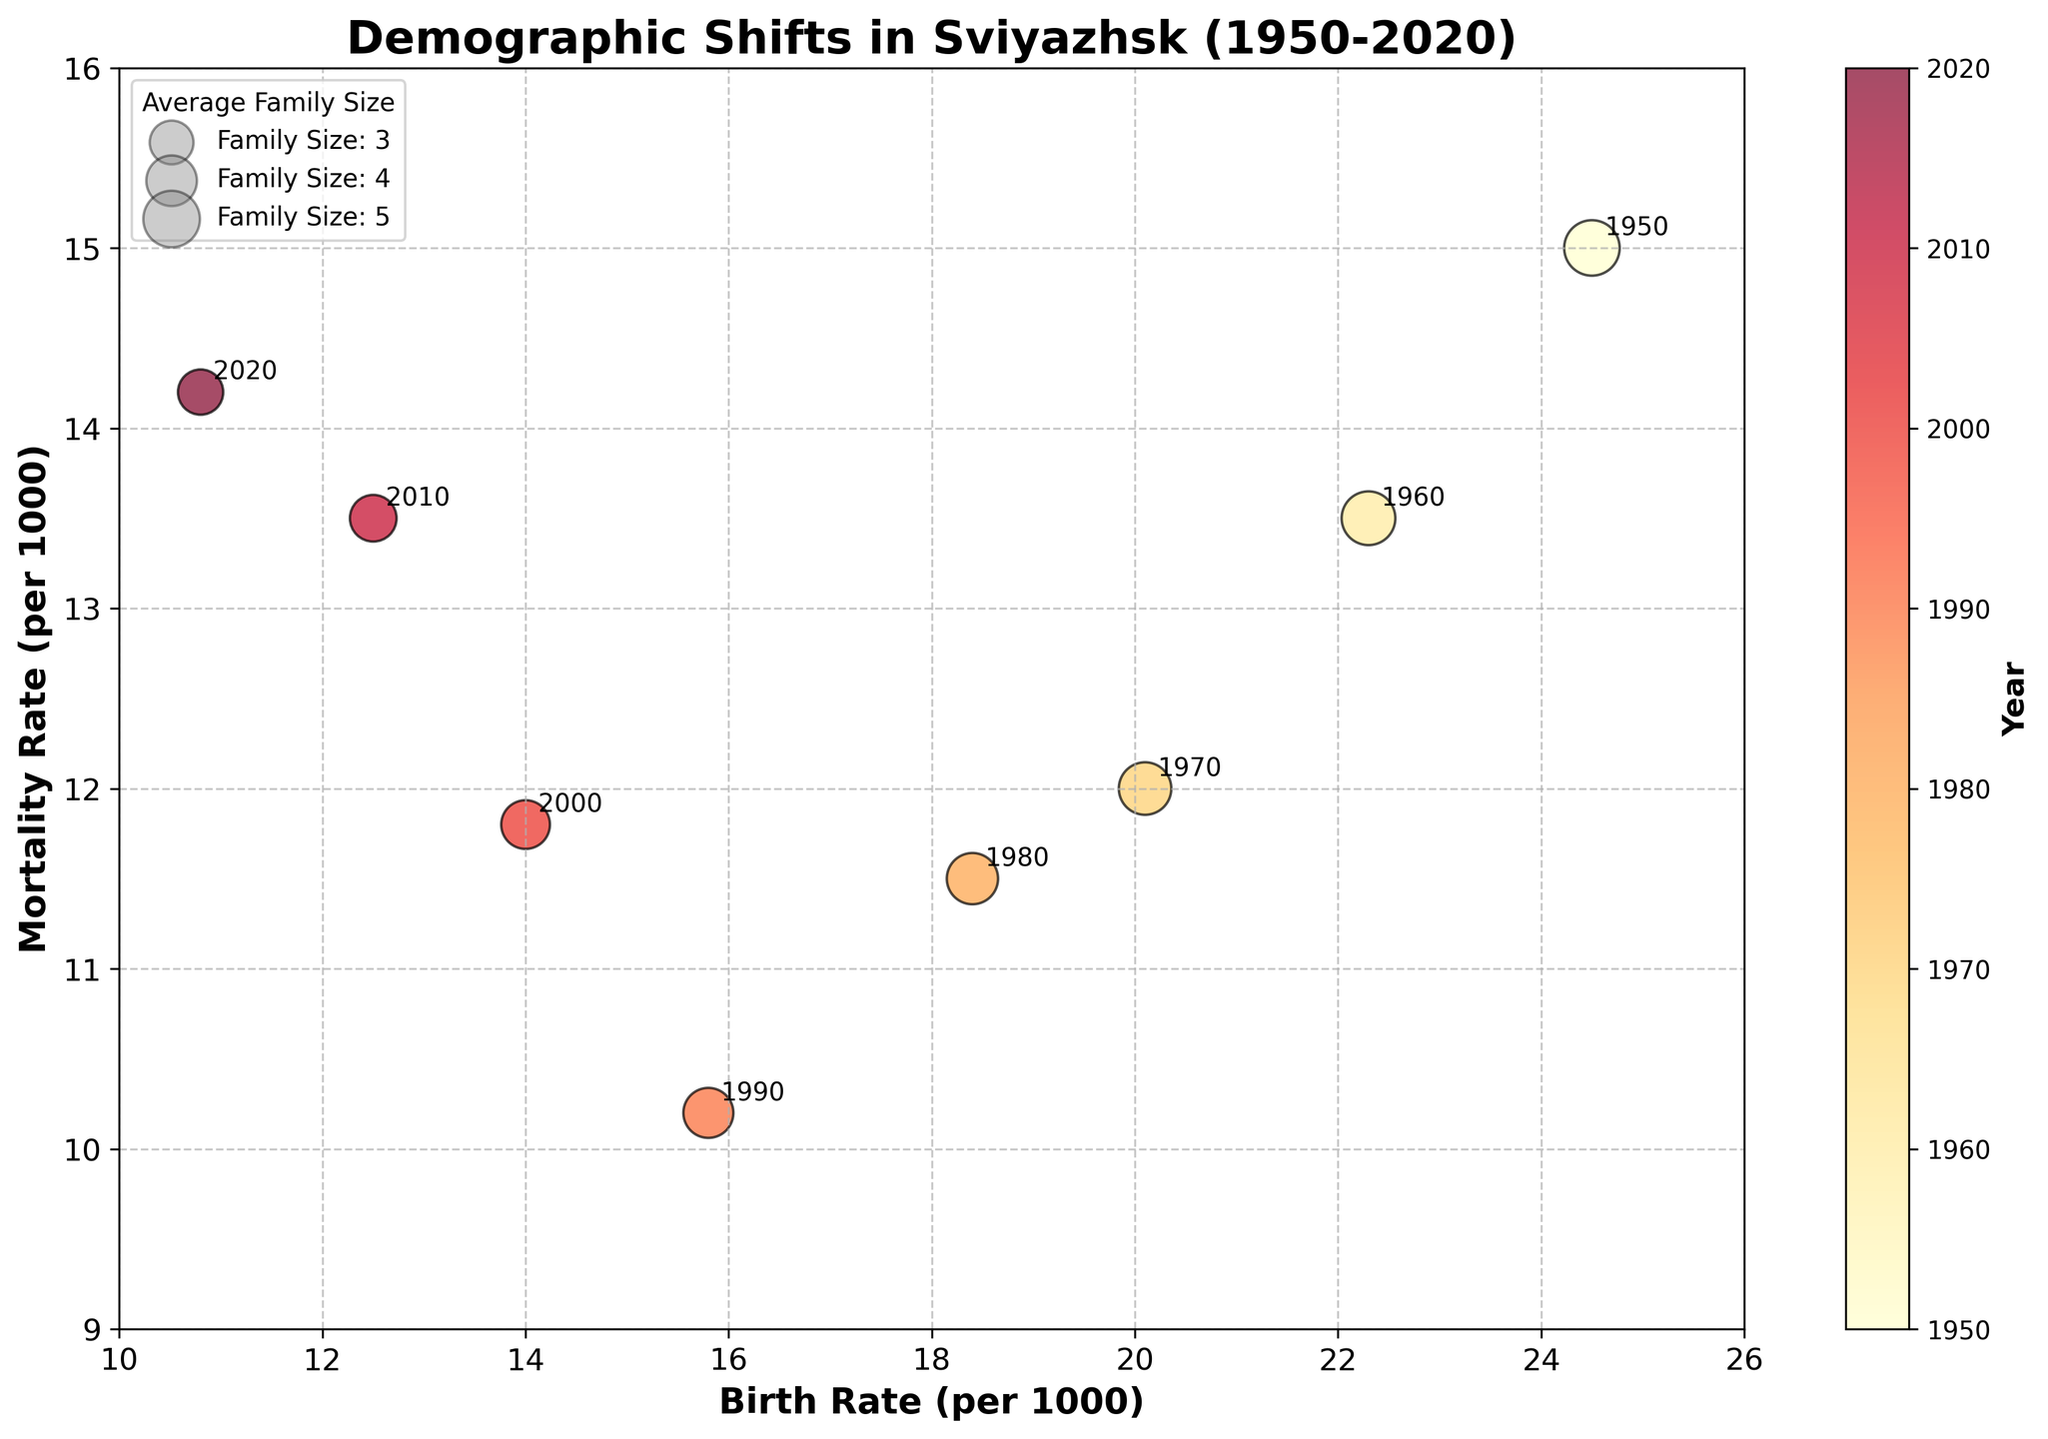What is the title of the bubble chart? The title of the bubble chart is located at the top center of the plot and usually is the largest text, providing an overview of what the chart represents.
Answer: Demographic Shifts in Sviyazhsk (1950-2020) What is the highest birth rate reported in the chart? The birth rate values are plotted on the x-axis. Find the data point with the highest value on this axis.
Answer: 24.5 (in 1950) What is the average family size in 1970? Look for the data point labeled with the year 1970, and check the bubble legend to see the corresponding average family size.
Answer: 4.3 Which year had the highest mortality rate? The mortality rates are indicated on the y-axis. Identify the year associated with the highest point on this axis.
Answer: 2020 How did the average family size change from 1950 to 2020? Compare the sizes of the bubbles labeled 1950 and 2020. The sizes represent the average family size.
Answer: It decreased from 4.8 to 3.2 What's the difference in birth rate between 1980 and 2000? Find the birth rate values on the x-axis for the years 1980 and 2000, then subtract the latter from the former.
Answer: 18.4 - 14.0 = 4.4 Which decade saw a decrease in both birth rate and mortality rate? Compare each decade to see where both the x-axis (birth rate) and y-axis (mortality rate) values decreased.
Answer: 1950-1960 What is the relationship between birth rate and mortality rate over time? Analyze the scatter plot to see if there's a trend in how these two values change over the decades.
Answer: Both have generally decreased, but birth rates decreased faster than mortality rates Which year had the smallest average family size? Look at the sizes of all the bubbles and find the one with the smallest diameter and the corresponding year.
Answer: 2020 Was there any year where the birth rate was lower than the mortality rate? Compare each data point's birth rate on the x-axis with its mortality rate on the y-axis to see if any x-value is lower than its corresponding y-value.
Answer: No 